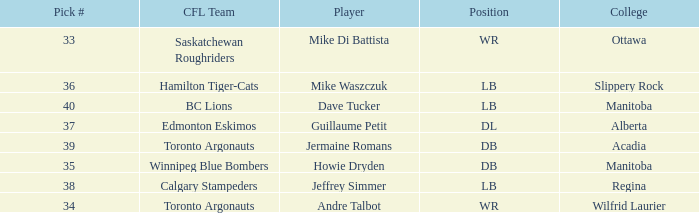What College has a Player that is jermaine romans? Acadia. 